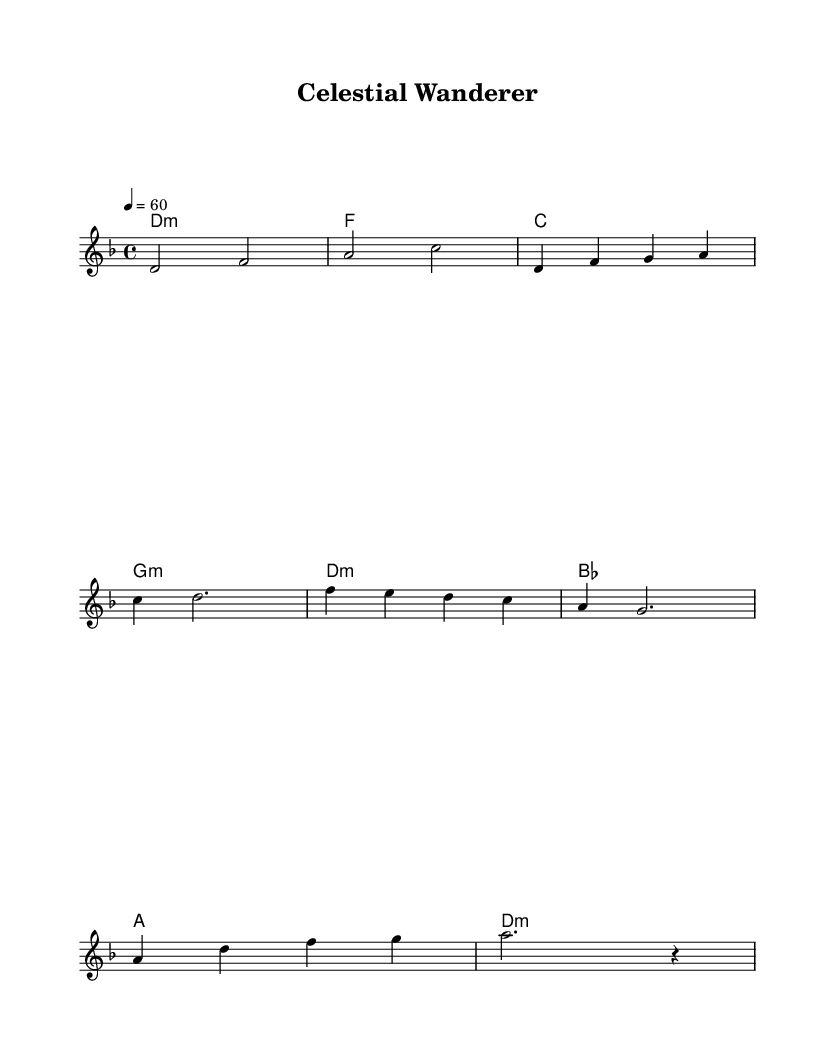What is the key signature of this music? The key signature is indicated at the beginning of the sheet music. Here, it shows two flats which means it is in D minor.
Answer: D minor What is the time signature of this piece? The time signature is found at the beginning of the score. Here, it is indicated as 4/4, meaning there are four beats per measure and the quarter note gets the beat.
Answer: 4/4 What is the tempo marking of the piece? The tempo marking is located at the beginning above the staff, which states "4 = 60". This indicates that the quarter note is to be played at 60 beats per minute.
Answer: 60 How many measures are in the melody section? To find this, count the distinct measures in the melody part. There are a total of 8 measures in the melody section before reaching the chorus.
Answer: 8 What is the first chord in the harmony? The first chord can be seen in the chord names section at the beginning. It is labeled as D minor, which is consistent with the piece's key signature.
Answer: D minor Which section follows the verse? The sections are typically marked by their function. After the verse, the next section indicated is the chorus, as it creates a contrast melody that follows.
Answer: Chorus What mood does the music evoke based on its key and tempo? The D minor key generally evokes a more somber or introspective mood, and combined with the slow tempo of 60 bpm, it creates a tranquil and reflective atmosphere, reminiscent of stargazing at night.
Answer: Reflective 